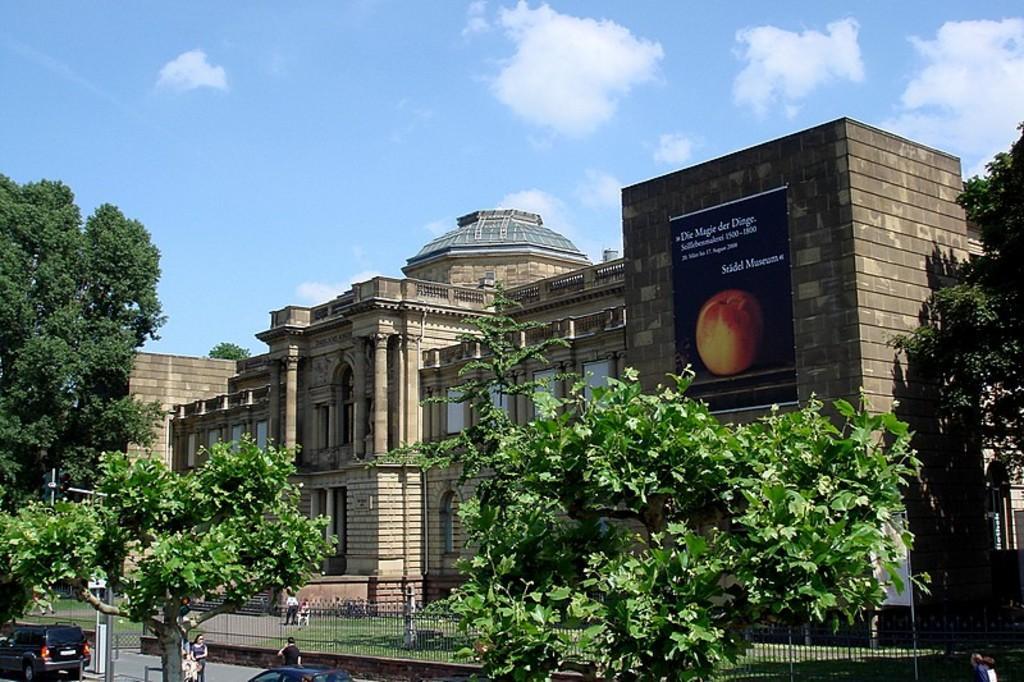How would you summarize this image in a sentence or two? Here there is a building with windows and poster on it, here there are trees, this is sky. 